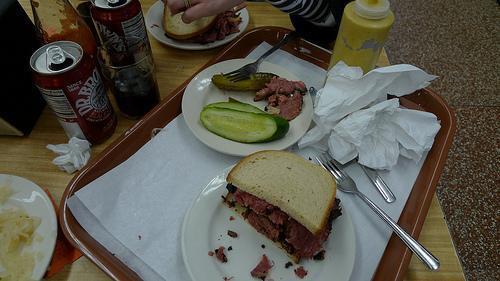How many mustard bottles are visible?
Give a very brief answer. 1. How many plates are visible?
Give a very brief answer. 4. 